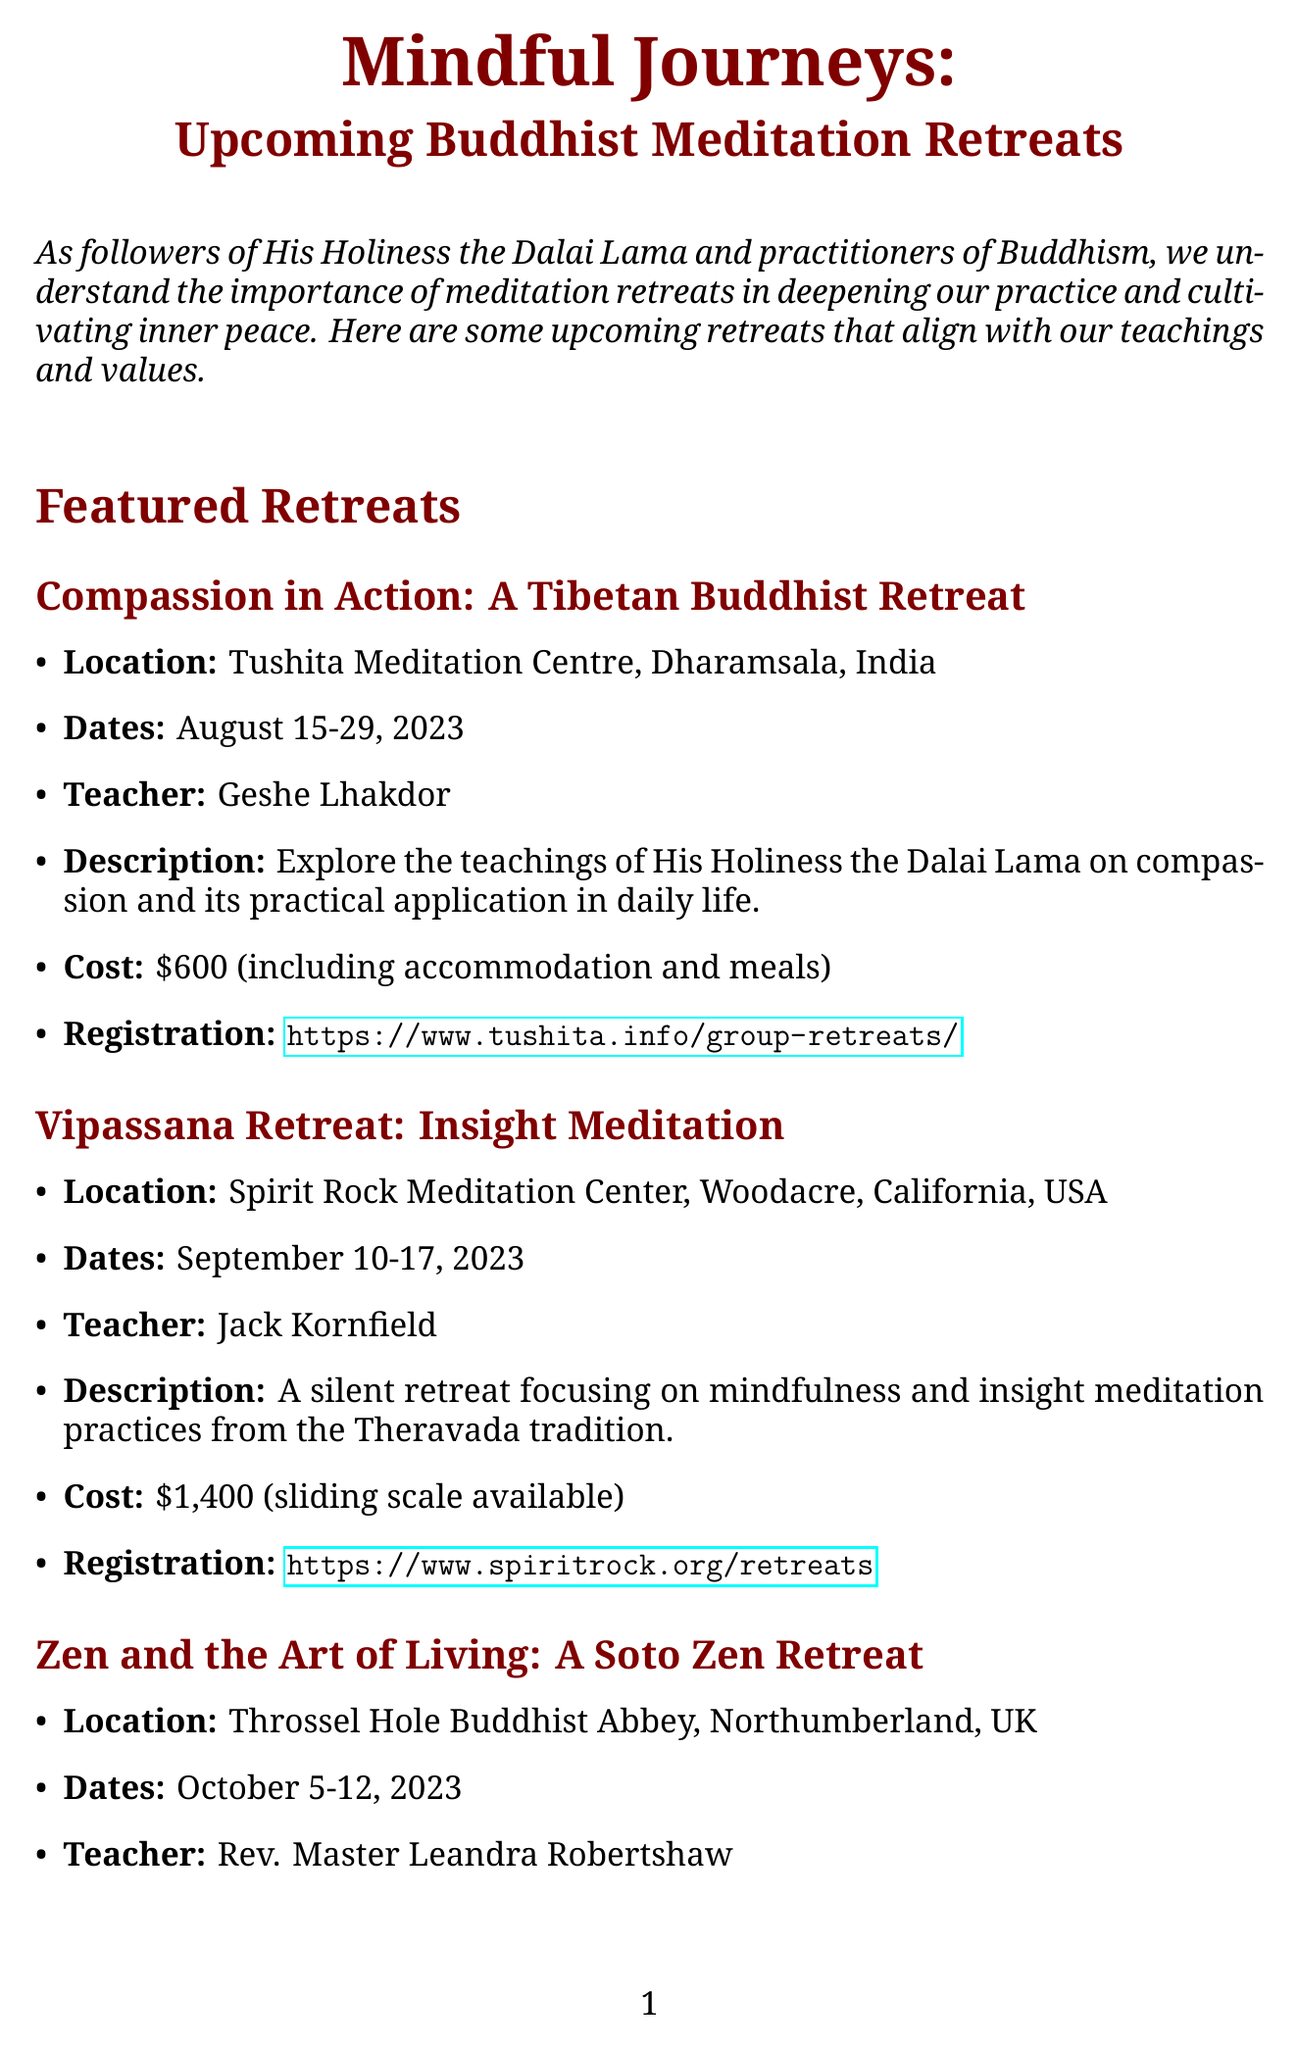What is the title of the newsletter? The title of the newsletter is mentioned prominently at the beginning of the document.
Answer: Mindful Journeys: Upcoming Buddhist Meditation Retreats Where is the Compassion in Action retreat located? The location is specifically listed for each featured retreat in the document.
Answer: Tushita Meditation Centre, Dharamsala, India Who is the teacher for the Vipassana Retreat? The teacher's name is provided for each retreat under the featured section.
Answer: Jack Kornfield What are the dates for the Zen and the Art of Living retreat? The dates for each retreat are clearly outlined in their respective sections.
Answer: October 5-12, 2023 What is the cost of the Compassion in Action retreat? The cost is explicitly stated in each retreat's details.
Answer: $600 (including accommodation and meals) Which retreat is related to Buddhist compassion teachings? This question requires connecting the specific retreat with its teaching focus mentioned in the document.
Answer: Compassion in Action: A Tibetan Buddhist Retreat What is the purpose of the additional resources section? The additional resources provide further reading and preparation tips for meditation retreats, offering complementary material.
Answer: To offer helpful tips and teachings What is the theme of the retreat led by Rev. Master Leandra Robertshaw? The themes of the retreats link the name with their descriptions in the document, requiring consideration of multiple pieces of information.
Answer: Zen practices and their relevance to contemporary life 